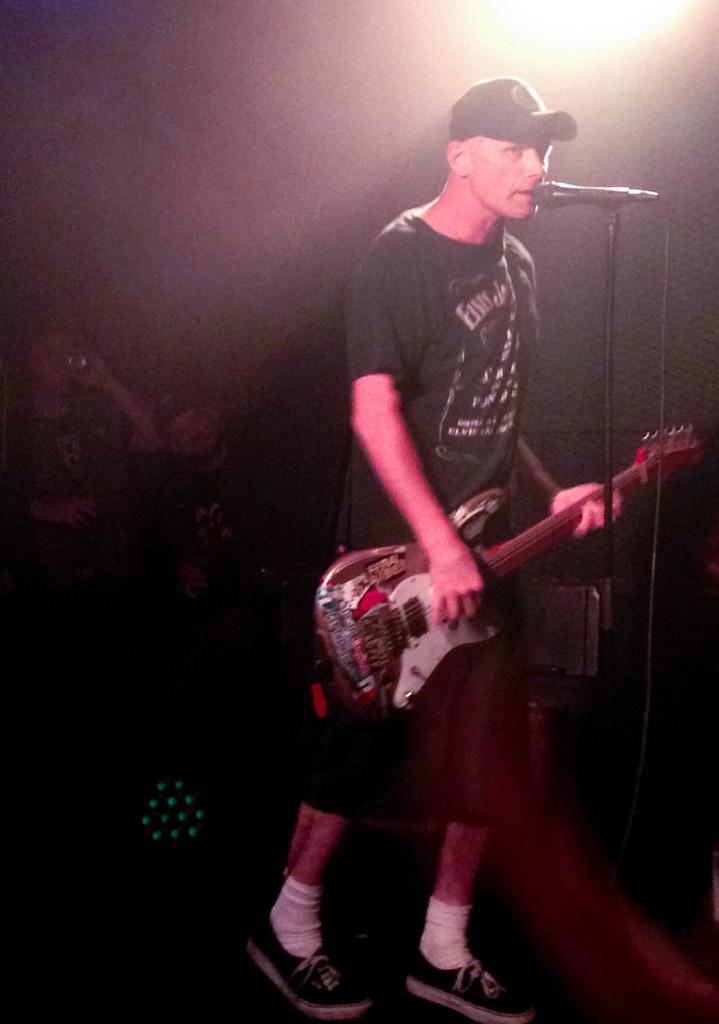Who is the main subject in the image? There is a man in the image. Where is the man located in the image? The man is standing on a stage. What is the man holding in the image? The man is holding a guitar. What is the man wearing in the image? The man is wearing a cap. What is the man doing in the image? The man is singing in front of a microphone and a stand. What can be seen in the background of the image? There is a light in the background of the image. Can you see any cobwebs in the image? There are no cobwebs present in the image. What riddle is the man trying to solve in the image? The man is not trying to solve a riddle in the image; he is singing with a guitar. 